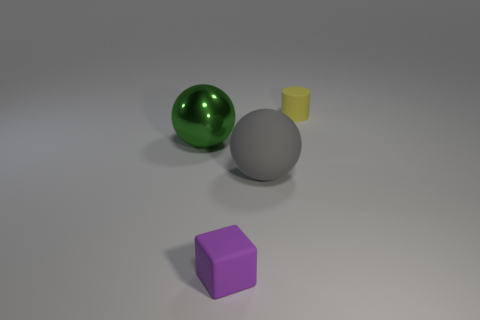There is a small thing in front of the shiny object; does it have the same shape as the big object that is right of the small matte cube? no 